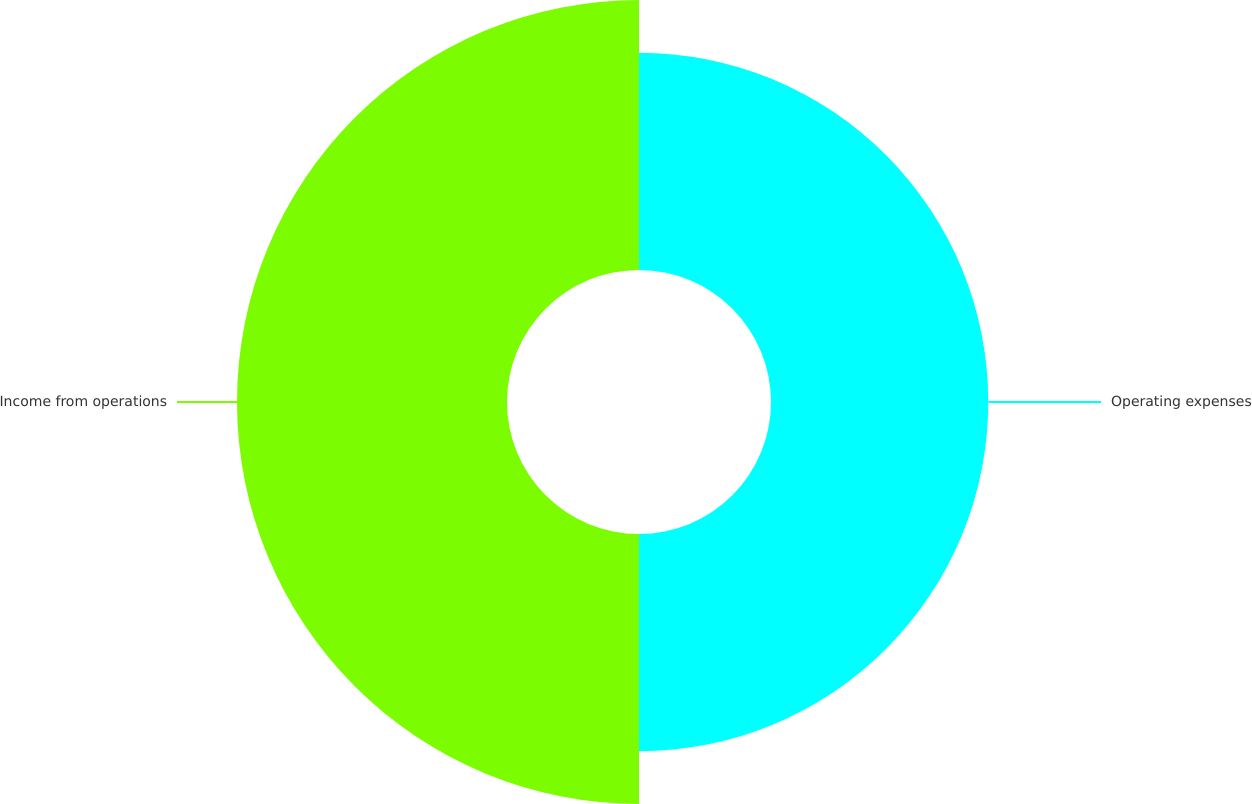Convert chart. <chart><loc_0><loc_0><loc_500><loc_500><pie_chart><fcel>Operating expenses<fcel>Income from operations<nl><fcel>44.59%<fcel>55.41%<nl></chart> 